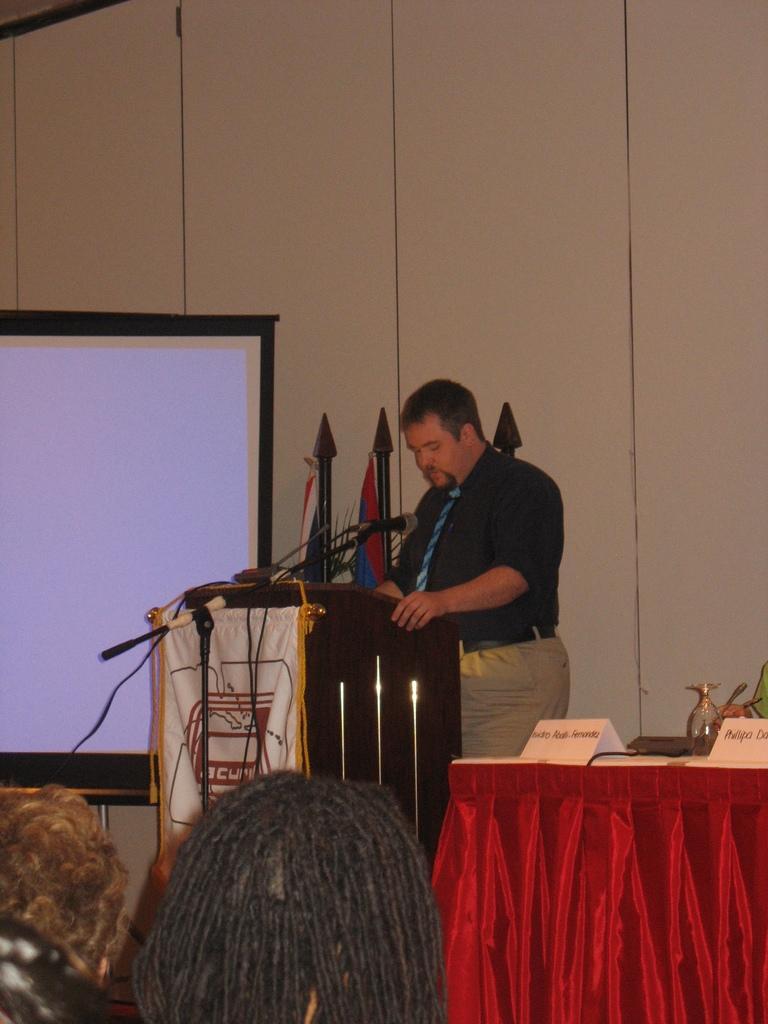In one or two sentences, can you explain what this image depicts? In this image there are persons heads towards the bottom of the image, there is a table towards the right of the image, there is a cloth towards the right of the image, there are objects on the table, there is a man standing and talking, there is a podium, there is a stand, there is a microphone, there are wires, there is a banner, there is text on the banner, there are flags, there are poles, there is a screen towards the left of the image, at the background of the image there is a wall. 